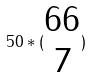<formula> <loc_0><loc_0><loc_500><loc_500>5 0 * ( \begin{matrix} 6 6 \\ 7 \end{matrix} )</formula> 